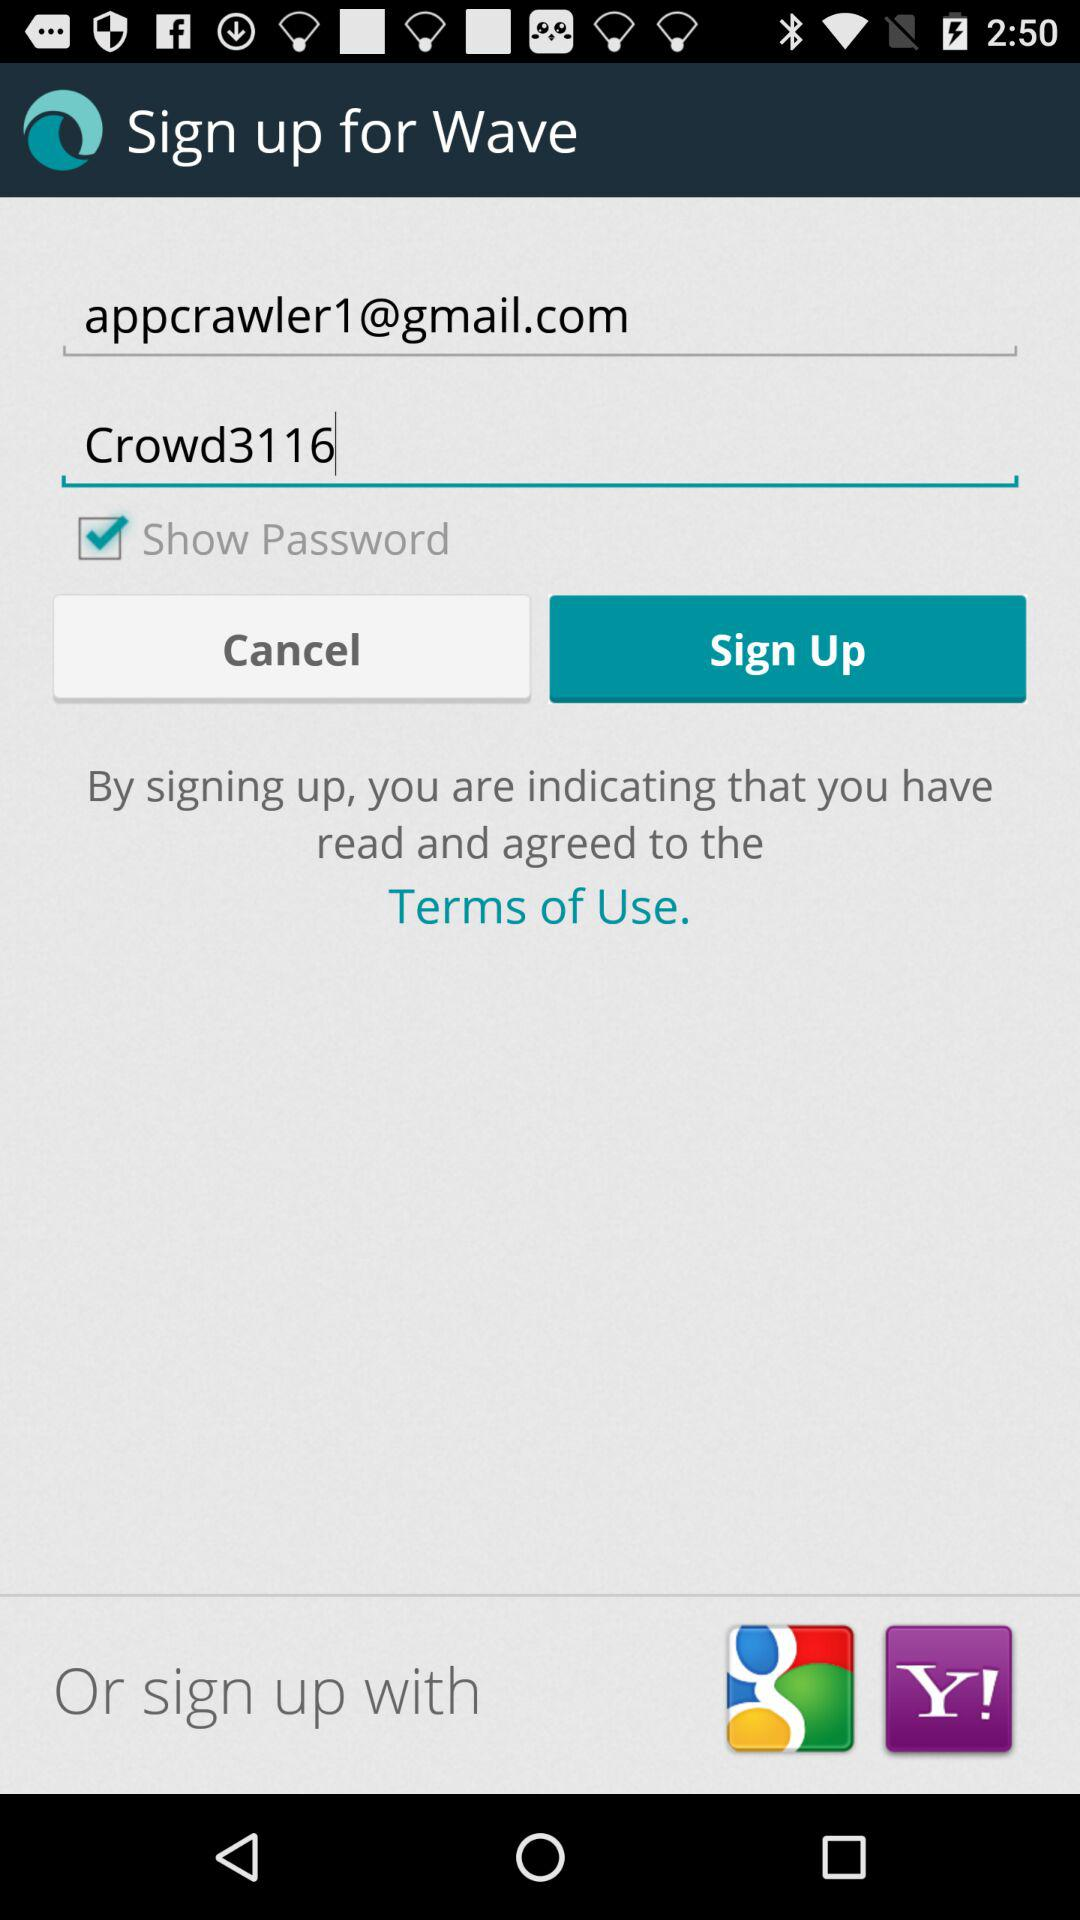What is the name of the application? The name of the application is "Wave". 